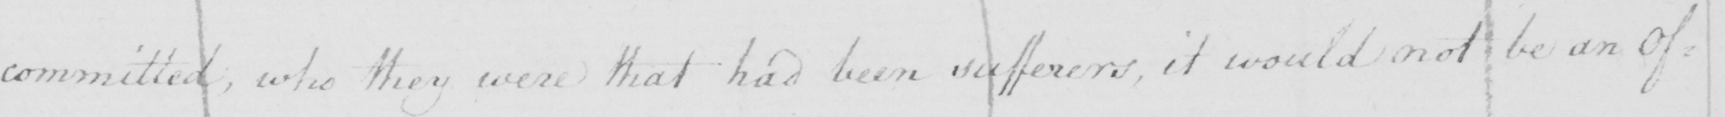What is written in this line of handwriting? committed , who they were that had been sufferers , it would not be an Of= 